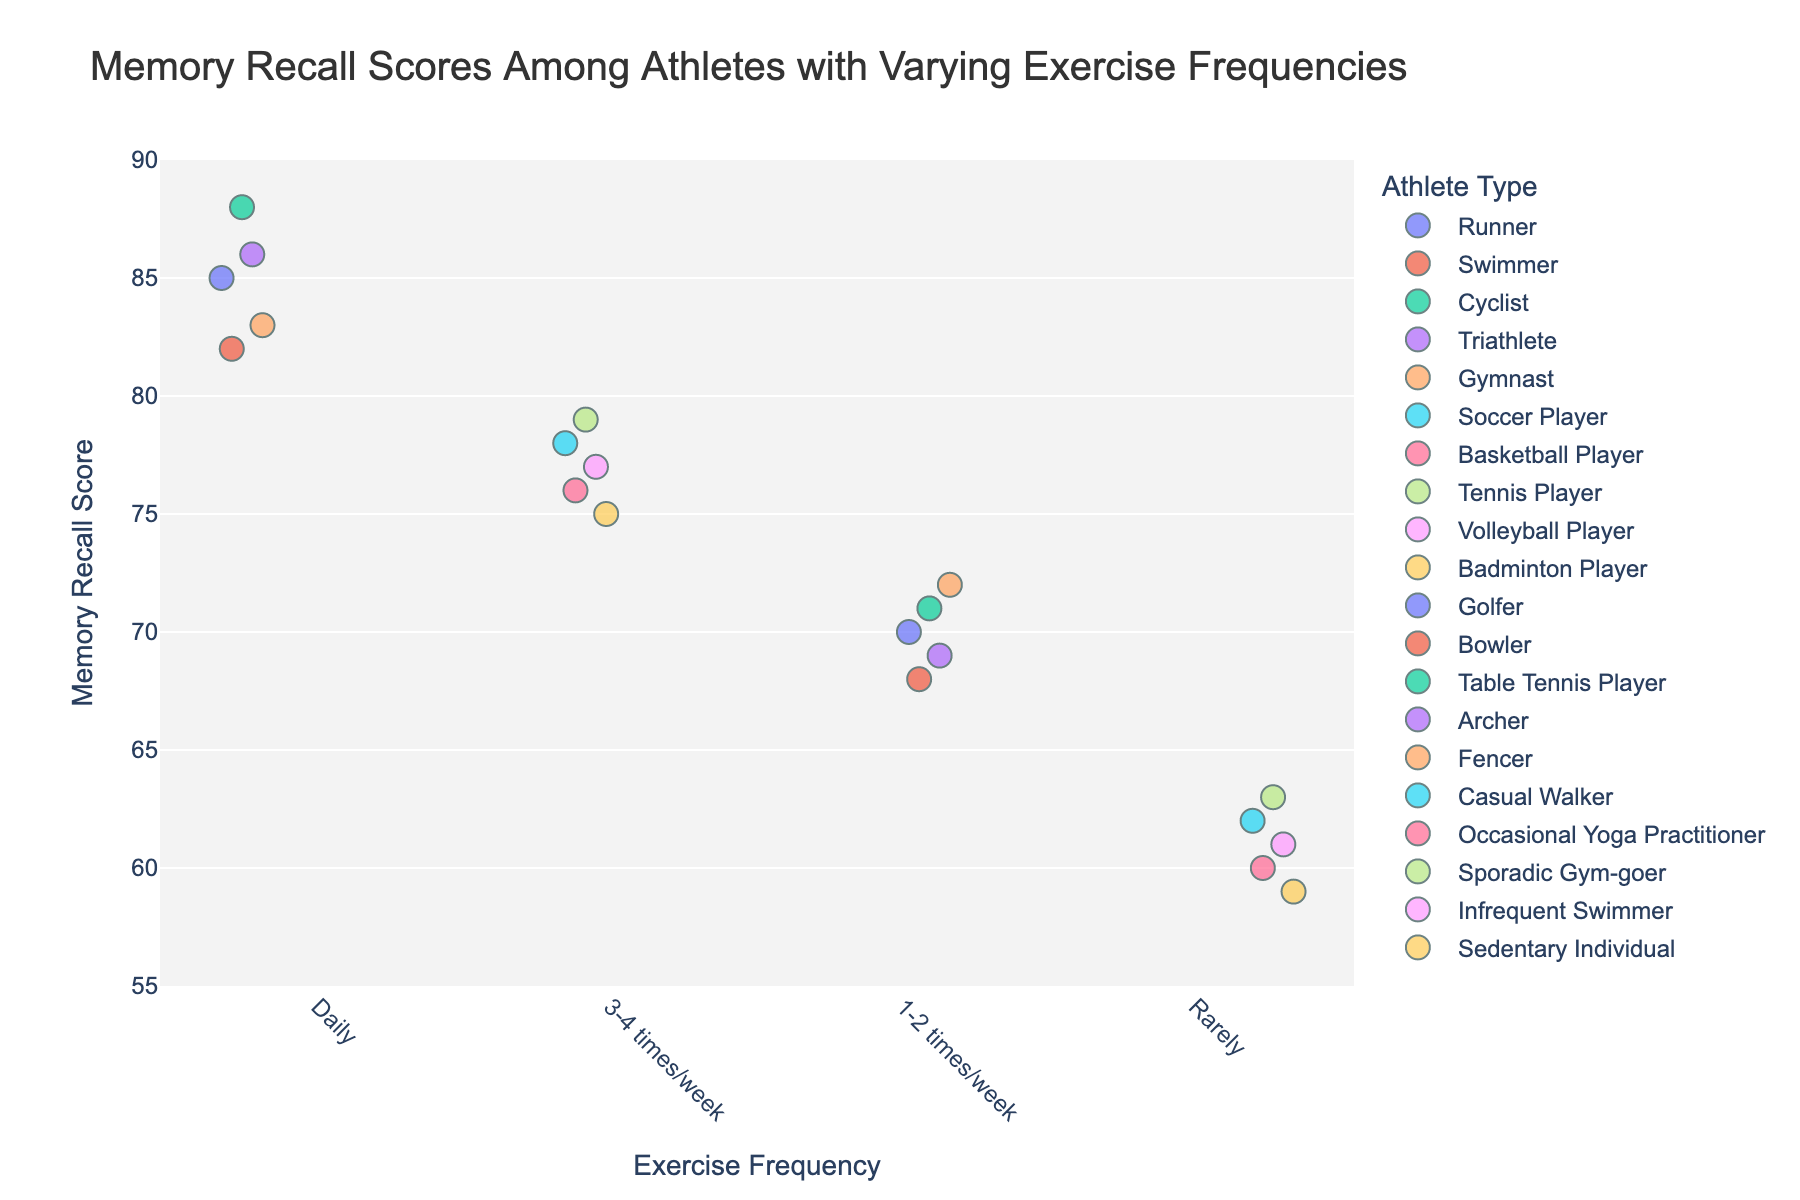What is the title of the plot? The title of the plot is found at the top of the figure, which gives an overview of what the plot represents.
Answer: Memory Recall Scores Among Athletes with Varying Exercise Frequencies What are the exercise frequency categories in the plot? The exercise frequency categories are listed along the x-axis, representing different groups in the data.
Answer: Daily, 3-4 times/week, 1-2 times/week, Rarely How many athletes fall under the "Daily" exercise frequency category? Count the number of data points (markers) in the "Daily" exercise frequency category strip.
Answer: 5 What's the range of memory recall scores for athletes exercising "3-4 times/week"? Determine the minimum and maximum scores for athletes in the "3-4 times/week" category.
Answer: 75 to 79 Which exercise frequency category exhibits the highest average memory recall score? Calculate the average score for each exercise frequency category and identify the one with the highest average. The "Daily" category seems to show the highest average by visual inspection.
Answer: Daily Is there any overlap in memory recall scores between "1-2 times/week" and "Rarely"? Check if there are any scores shared by both "1-2 times/week" and "Rarely". For example, see if any score in "1-2 times/week" falls within the range of scores in "Rarely".
Answer: No On average, how much higher are the scores for daily exercisers compared to those who exercise rarely? Calculate the average scores for both groups and subtract the average for "Rarely" from the average for "Daily".
Answer: 24 Which athlete type within the "Rarely" category has the highest memory recall score, and what is it? Identify the athlete type with the highest score by looking at the color-coded markers and the scores.
Answer: Sporadic Gym-goer with 63 Can you identify any outlier in the category "Daily"? If yes, what is it? Check for data points that significantly differ from the rest within the "Daily" category.
Answer: No, there are no obvious outliers What is the median memory recall score for athletes exercising "1-2 times/week"? Sort the scores for "1-2 times/week" and find the middle value.
Answer: 70 